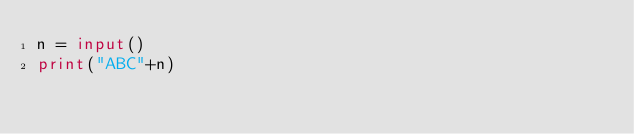Convert code to text. <code><loc_0><loc_0><loc_500><loc_500><_Python_>n = input()
print("ABC"+n)</code> 